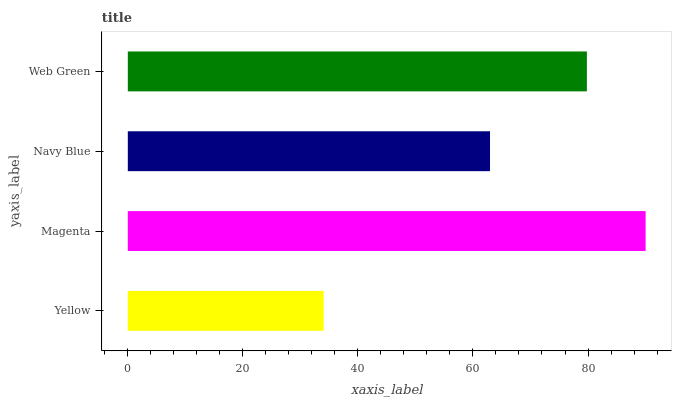Is Yellow the minimum?
Answer yes or no. Yes. Is Magenta the maximum?
Answer yes or no. Yes. Is Navy Blue the minimum?
Answer yes or no. No. Is Navy Blue the maximum?
Answer yes or no. No. Is Magenta greater than Navy Blue?
Answer yes or no. Yes. Is Navy Blue less than Magenta?
Answer yes or no. Yes. Is Navy Blue greater than Magenta?
Answer yes or no. No. Is Magenta less than Navy Blue?
Answer yes or no. No. Is Web Green the high median?
Answer yes or no. Yes. Is Navy Blue the low median?
Answer yes or no. Yes. Is Navy Blue the high median?
Answer yes or no. No. Is Magenta the low median?
Answer yes or no. No. 